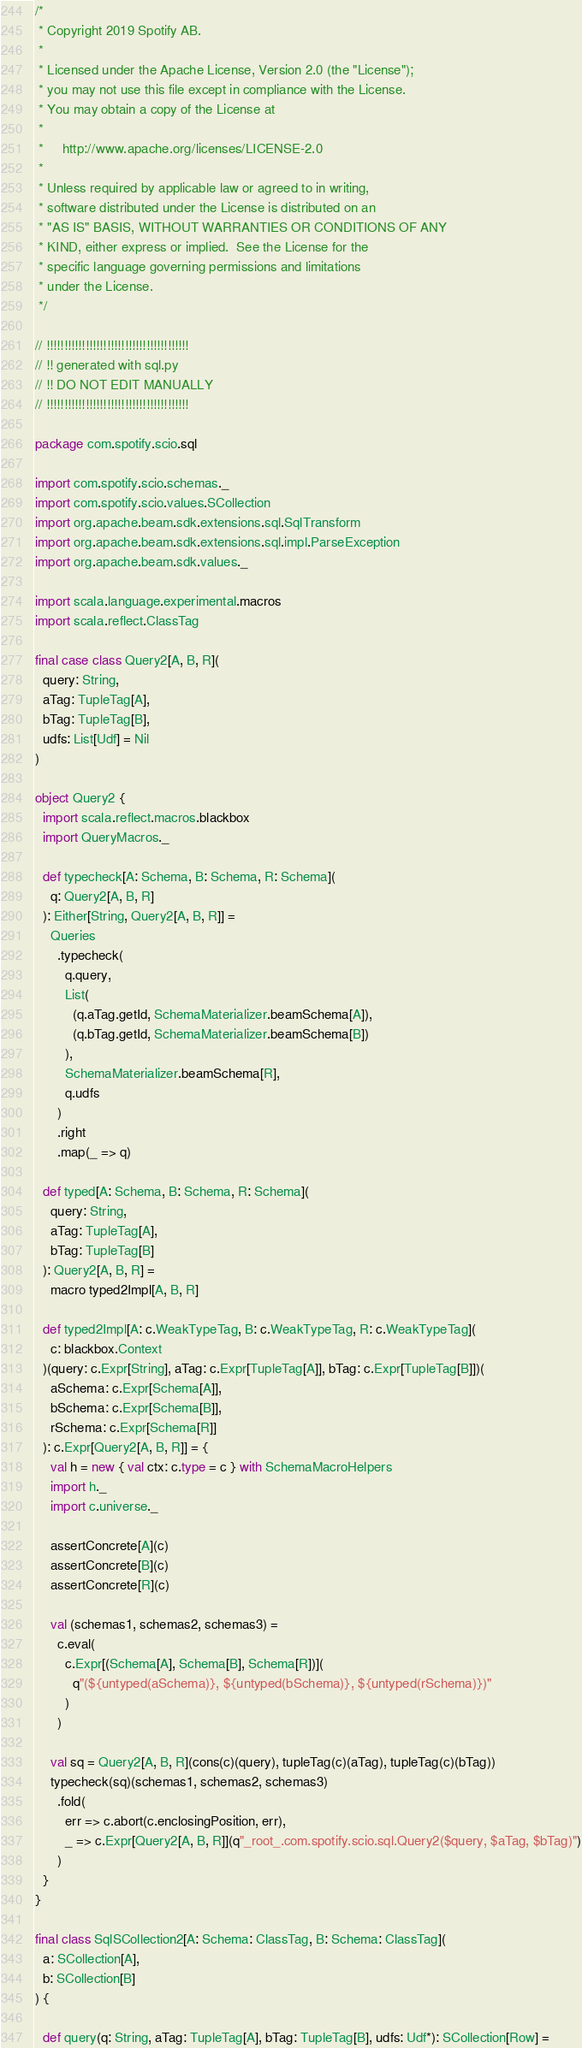Convert code to text. <code><loc_0><loc_0><loc_500><loc_500><_Scala_>/*
 * Copyright 2019 Spotify AB.
 *
 * Licensed under the Apache License, Version 2.0 (the "License");
 * you may not use this file except in compliance with the License.
 * You may obtain a copy of the License at
 *
 *     http://www.apache.org/licenses/LICENSE-2.0
 *
 * Unless required by applicable law or agreed to in writing,
 * software distributed under the License is distributed on an
 * "AS IS" BASIS, WITHOUT WARRANTIES OR CONDITIONS OF ANY
 * KIND, either express or implied.  See the License for the
 * specific language governing permissions and limitations
 * under the License.
 */

// !!!!!!!!!!!!!!!!!!!!!!!!!!!!!!!!!!!!!!!!
// !! generated with sql.py
// !! DO NOT EDIT MANUALLY
// !!!!!!!!!!!!!!!!!!!!!!!!!!!!!!!!!!!!!!!!

package com.spotify.scio.sql

import com.spotify.scio.schemas._
import com.spotify.scio.values.SCollection
import org.apache.beam.sdk.extensions.sql.SqlTransform
import org.apache.beam.sdk.extensions.sql.impl.ParseException
import org.apache.beam.sdk.values._

import scala.language.experimental.macros
import scala.reflect.ClassTag

final case class Query2[A, B, R](
  query: String,
  aTag: TupleTag[A],
  bTag: TupleTag[B],
  udfs: List[Udf] = Nil
)

object Query2 {
  import scala.reflect.macros.blackbox
  import QueryMacros._

  def typecheck[A: Schema, B: Schema, R: Schema](
    q: Query2[A, B, R]
  ): Either[String, Query2[A, B, R]] =
    Queries
      .typecheck(
        q.query,
        List(
          (q.aTag.getId, SchemaMaterializer.beamSchema[A]),
          (q.bTag.getId, SchemaMaterializer.beamSchema[B])
        ),
        SchemaMaterializer.beamSchema[R],
        q.udfs
      )
      .right
      .map(_ => q)

  def typed[A: Schema, B: Schema, R: Schema](
    query: String,
    aTag: TupleTag[A],
    bTag: TupleTag[B]
  ): Query2[A, B, R] =
    macro typed2Impl[A, B, R]

  def typed2Impl[A: c.WeakTypeTag, B: c.WeakTypeTag, R: c.WeakTypeTag](
    c: blackbox.Context
  )(query: c.Expr[String], aTag: c.Expr[TupleTag[A]], bTag: c.Expr[TupleTag[B]])(
    aSchema: c.Expr[Schema[A]],
    bSchema: c.Expr[Schema[B]],
    rSchema: c.Expr[Schema[R]]
  ): c.Expr[Query2[A, B, R]] = {
    val h = new { val ctx: c.type = c } with SchemaMacroHelpers
    import h._
    import c.universe._

    assertConcrete[A](c)
    assertConcrete[B](c)
    assertConcrete[R](c)

    val (schemas1, schemas2, schemas3) =
      c.eval(
        c.Expr[(Schema[A], Schema[B], Schema[R])](
          q"(${untyped(aSchema)}, ${untyped(bSchema)}, ${untyped(rSchema)})"
        )
      )

    val sq = Query2[A, B, R](cons(c)(query), tupleTag(c)(aTag), tupleTag(c)(bTag))
    typecheck(sq)(schemas1, schemas2, schemas3)
      .fold(
        err => c.abort(c.enclosingPosition, err),
        _ => c.Expr[Query2[A, B, R]](q"_root_.com.spotify.scio.sql.Query2($query, $aTag, $bTag)")
      )
  }
}

final class SqlSCollection2[A: Schema: ClassTag, B: Schema: ClassTag](
  a: SCollection[A],
  b: SCollection[B]
) {

  def query(q: String, aTag: TupleTag[A], bTag: TupleTag[B], udfs: Udf*): SCollection[Row] =</code> 